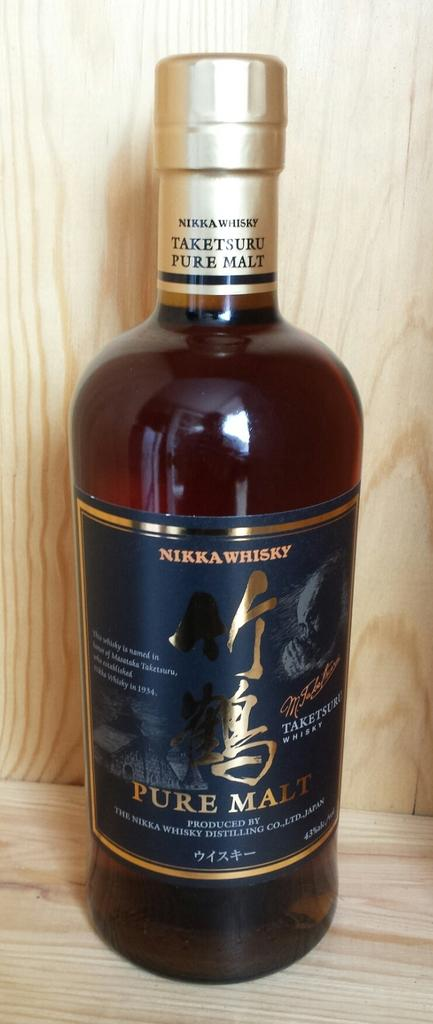Provide a one-sentence caption for the provided image. A bottle of NIKKA WHISKY from Japan titled PURE MALT. 